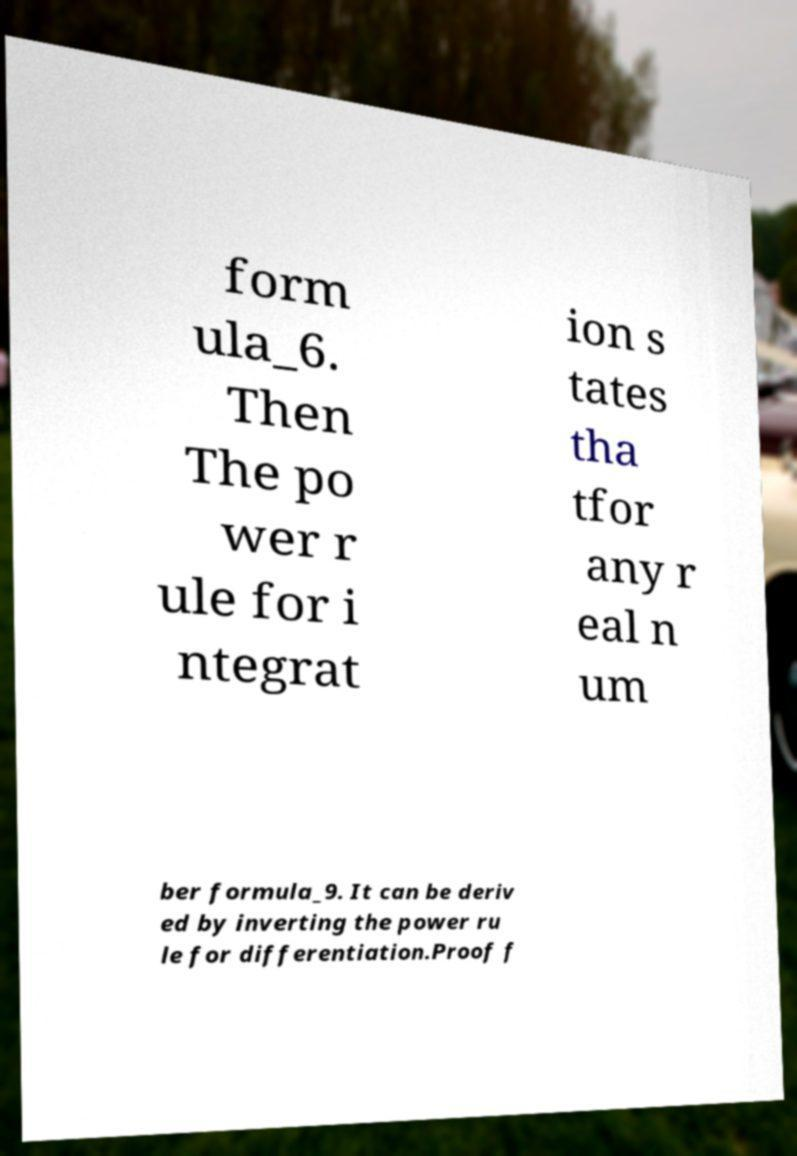What messages or text are displayed in this image? I need them in a readable, typed format. form ula_6. Then The po wer r ule for i ntegrat ion s tates tha tfor any r eal n um ber formula_9. It can be deriv ed by inverting the power ru le for differentiation.Proof f 